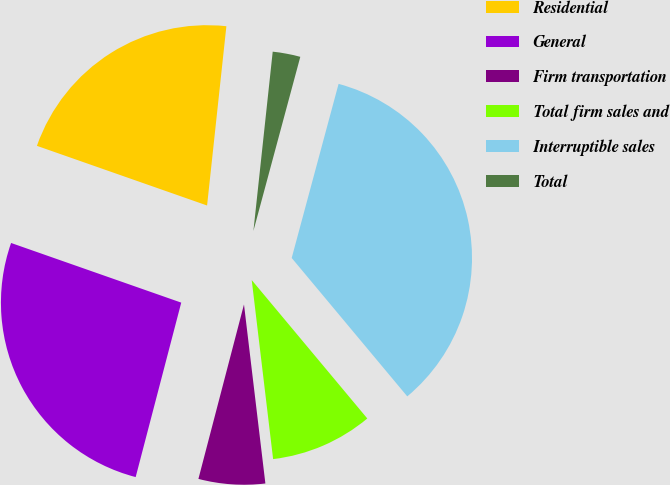Convert chart to OTSL. <chart><loc_0><loc_0><loc_500><loc_500><pie_chart><fcel>Residential<fcel>General<fcel>Firm transportation<fcel>Total firm sales and<fcel>Interruptible sales<fcel>Total<nl><fcel>21.34%<fcel>26.3%<fcel>5.96%<fcel>9.18%<fcel>34.74%<fcel>2.48%<nl></chart> 